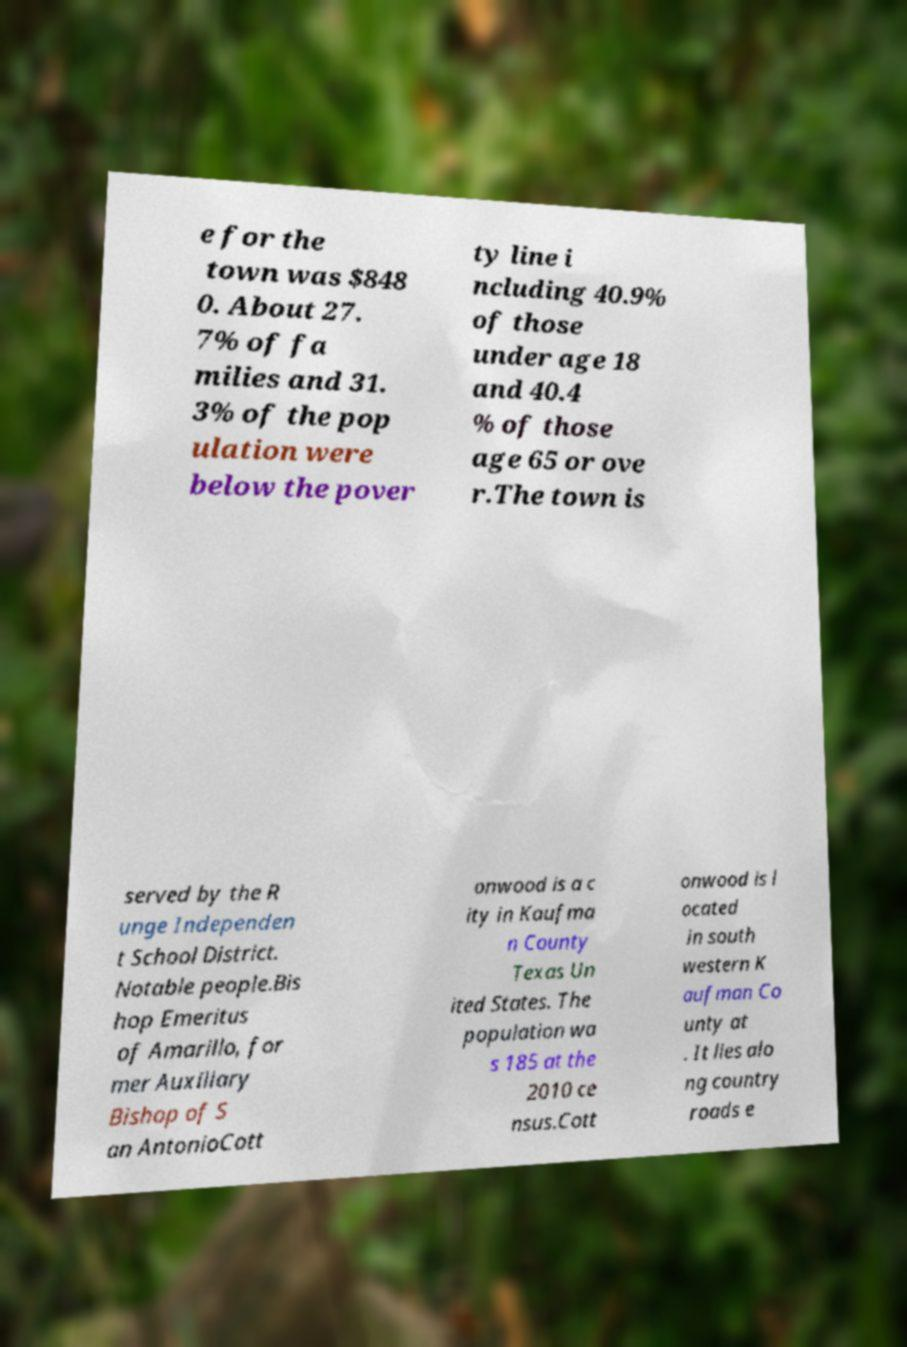Please read and relay the text visible in this image. What does it say? e for the town was $848 0. About 27. 7% of fa milies and 31. 3% of the pop ulation were below the pover ty line i ncluding 40.9% of those under age 18 and 40.4 % of those age 65 or ove r.The town is served by the R unge Independen t School District. Notable people.Bis hop Emeritus of Amarillo, for mer Auxiliary Bishop of S an AntonioCott onwood is a c ity in Kaufma n County Texas Un ited States. The population wa s 185 at the 2010 ce nsus.Cott onwood is l ocated in south western K aufman Co unty at . It lies alo ng country roads e 